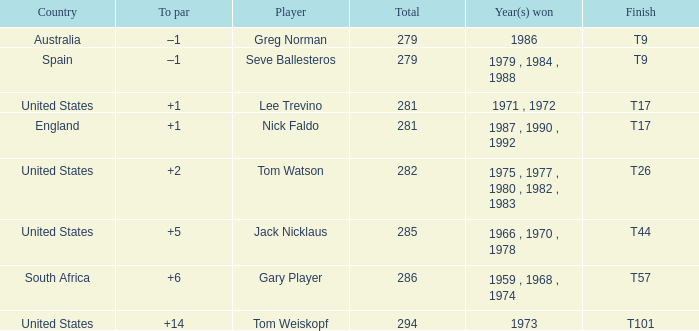Who has the highest total and a to par of +14? 294.0. 